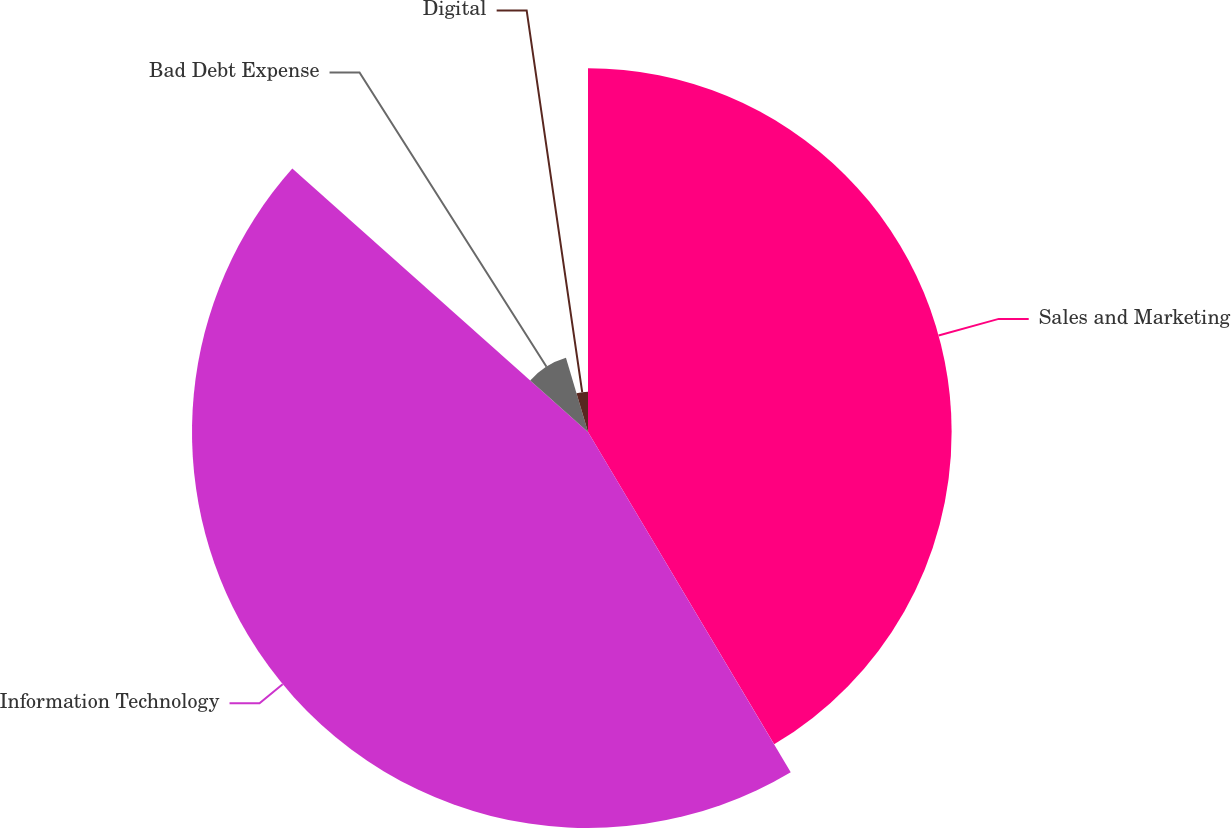Convert chart. <chart><loc_0><loc_0><loc_500><loc_500><pie_chart><fcel>Sales and Marketing<fcel>Information Technology<fcel>Bad Debt Expense<fcel>Digital<nl><fcel>41.45%<fcel>45.14%<fcel>8.82%<fcel>4.6%<nl></chart> 